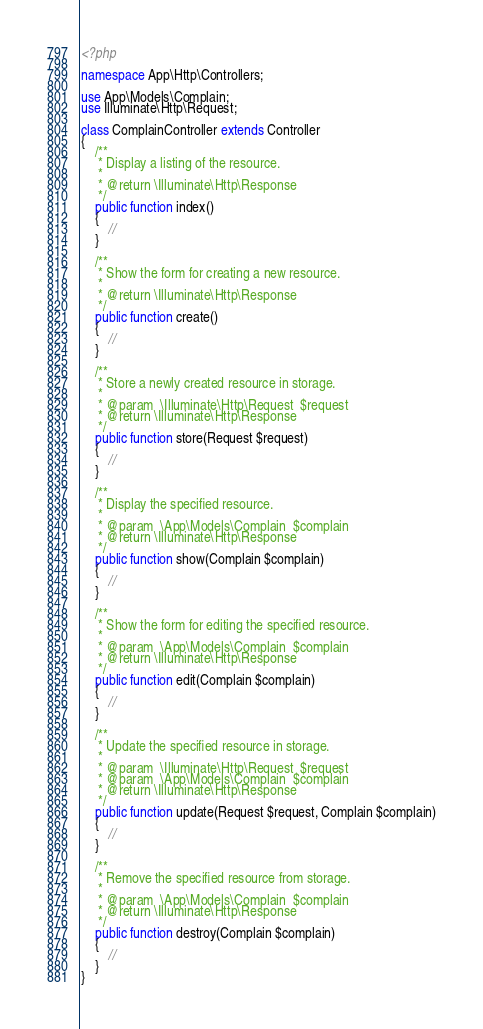Convert code to text. <code><loc_0><loc_0><loc_500><loc_500><_PHP_><?php

namespace App\Http\Controllers;

use App\Models\Complain;
use Illuminate\Http\Request;

class ComplainController extends Controller
{
    /**
     * Display a listing of the resource.
     *
     * @return \Illuminate\Http\Response
     */
    public function index()
    {
        //
    }

    /**
     * Show the form for creating a new resource.
     *
     * @return \Illuminate\Http\Response
     */
    public function create()
    {
        //
    }

    /**
     * Store a newly created resource in storage.
     *
     * @param  \Illuminate\Http\Request  $request
     * @return \Illuminate\Http\Response
     */
    public function store(Request $request)
    {
        //
    }

    /**
     * Display the specified resource.
     *
     * @param  \App\Models\Complain  $complain
     * @return \Illuminate\Http\Response
     */
    public function show(Complain $complain)
    {
        //
    }

    /**
     * Show the form for editing the specified resource.
     *
     * @param  \App\Models\Complain  $complain
     * @return \Illuminate\Http\Response
     */
    public function edit(Complain $complain)
    {
        //
    }

    /**
     * Update the specified resource in storage.
     *
     * @param  \Illuminate\Http\Request  $request
     * @param  \App\Models\Complain  $complain
     * @return \Illuminate\Http\Response
     */
    public function update(Request $request, Complain $complain)
    {
        //
    }

    /**
     * Remove the specified resource from storage.
     *
     * @param  \App\Models\Complain  $complain
     * @return \Illuminate\Http\Response
     */
    public function destroy(Complain $complain)
    {
        //
    }
}
</code> 